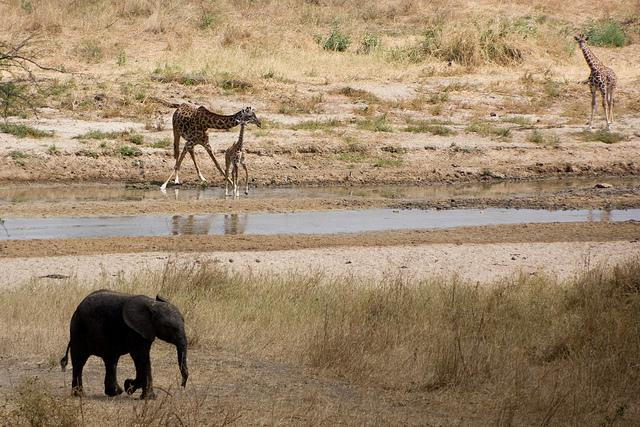Why does that animal have its legs spread? to drink 